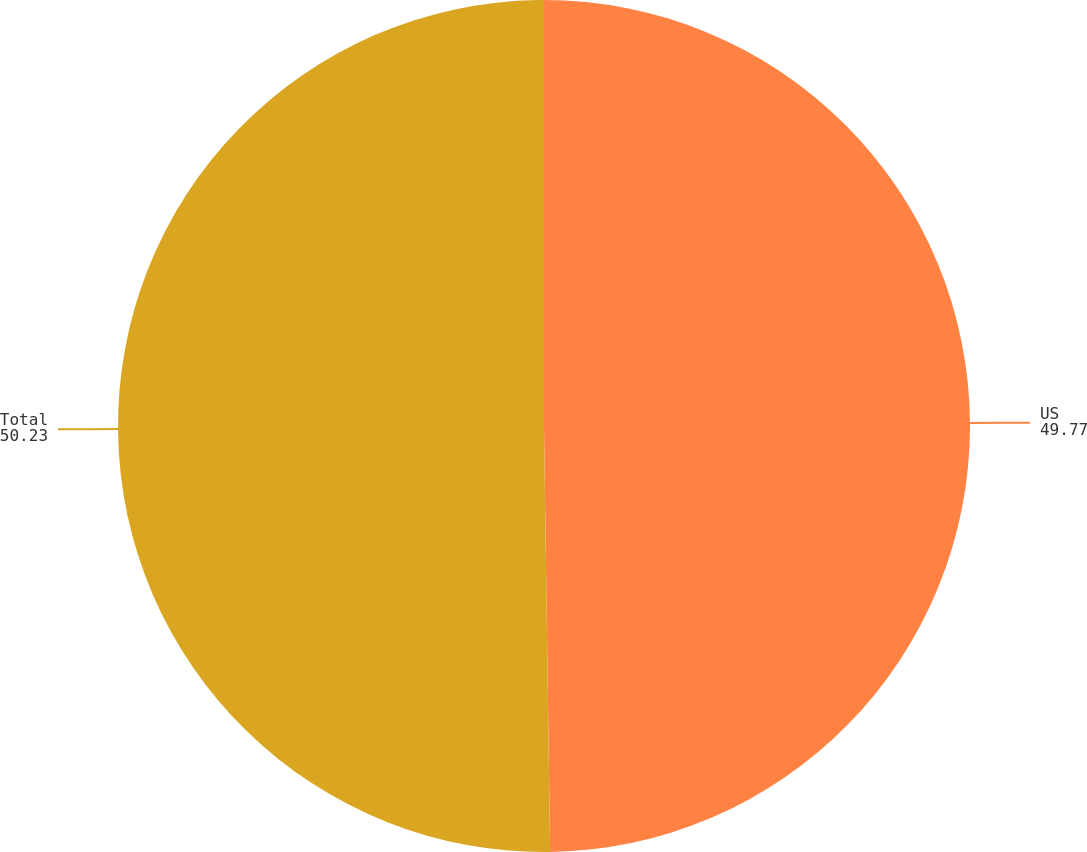Convert chart. <chart><loc_0><loc_0><loc_500><loc_500><pie_chart><fcel>US<fcel>Total<nl><fcel>49.77%<fcel>50.23%<nl></chart> 